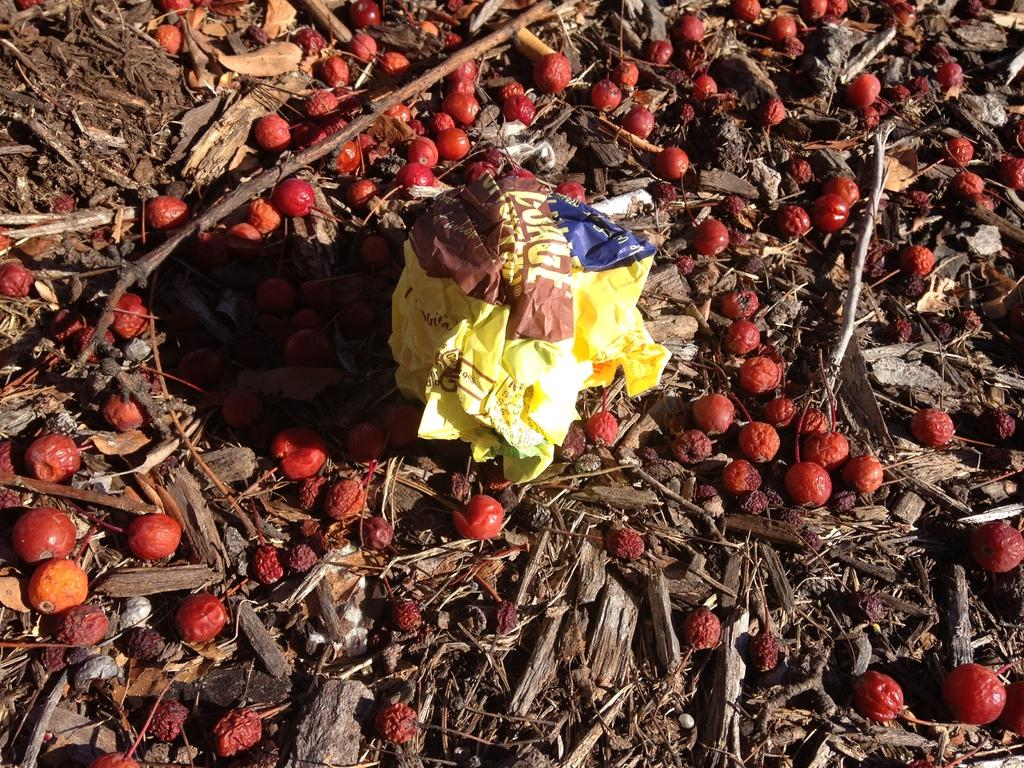What type of fruit can be seen on the ground in the image? There are berries on the ground in the image. What object is located in the middle of the image? There is a paper in the middle of the image. What else can be found on the ground in the image besides berries? Stems and dried leaves are present on the ground in the image. What type of quill can be seen in the image? There is no quill present in the image. Can you hear any sounds coming from the image? The image is silent, and no sounds can be heard. 